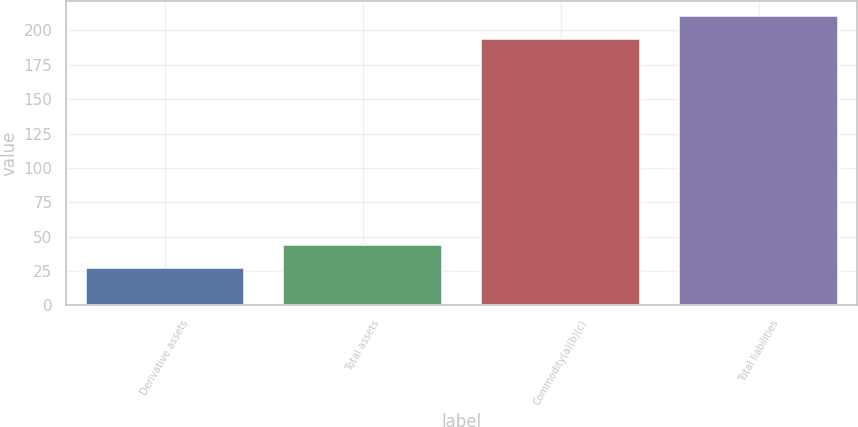Convert chart. <chart><loc_0><loc_0><loc_500><loc_500><bar_chart><fcel>Derivative assets<fcel>Total assets<fcel>Commodity(a)(b)(c)<fcel>Total liabilities<nl><fcel>27<fcel>43.7<fcel>194<fcel>210.7<nl></chart> 